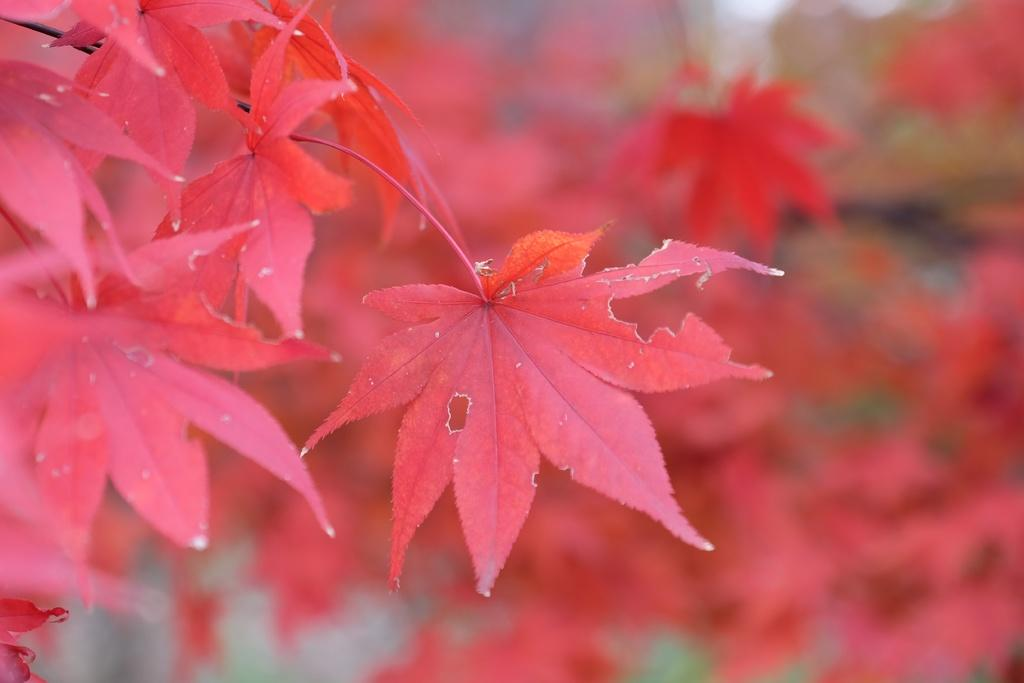What color are the leaves visible in the image? The leaves in the image are red. Can you describe the background of the image? The background of the image is blurry. What type of cave is depicted in the image? There is no cave present in the image; it features red leaves and a blurry background. How many bombs can be seen in the image? There are no bombs present in the image. 